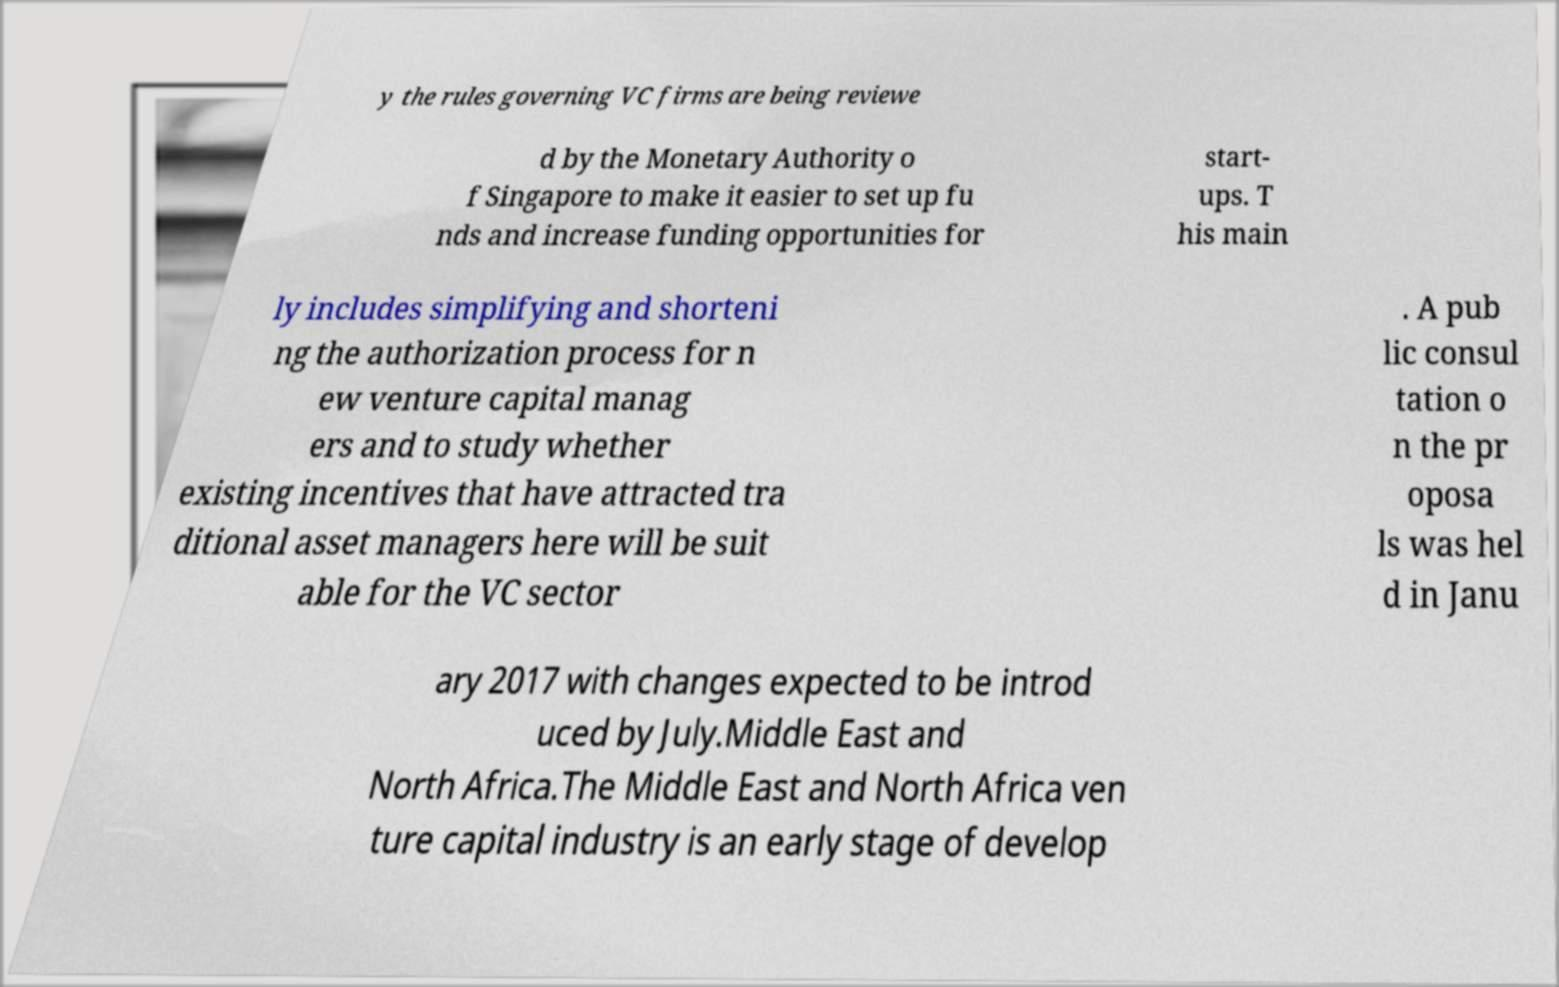Please read and relay the text visible in this image. What does it say? y the rules governing VC firms are being reviewe d by the Monetary Authority o f Singapore to make it easier to set up fu nds and increase funding opportunities for start- ups. T his main ly includes simplifying and shorteni ng the authorization process for n ew venture capital manag ers and to study whether existing incentives that have attracted tra ditional asset managers here will be suit able for the VC sector . A pub lic consul tation o n the pr oposa ls was hel d in Janu ary 2017 with changes expected to be introd uced by July.Middle East and North Africa.The Middle East and North Africa ven ture capital industry is an early stage of develop 